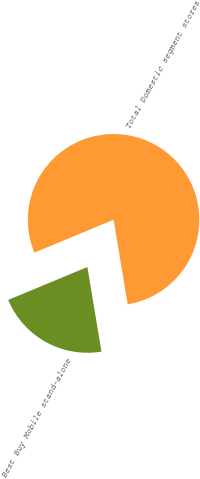<chart> <loc_0><loc_0><loc_500><loc_500><pie_chart><fcel>Best Buy Mobile stand-alone<fcel>Total Domestic segment stores<nl><fcel>21.36%<fcel>78.64%<nl></chart> 